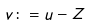<formula> <loc_0><loc_0><loc_500><loc_500>v \colon = u - Z</formula> 